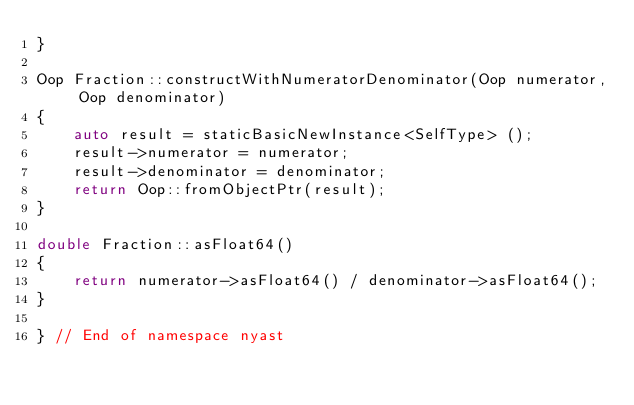Convert code to text. <code><loc_0><loc_0><loc_500><loc_500><_C++_>}

Oop Fraction::constructWithNumeratorDenominator(Oop numerator, Oop denominator)
{
    auto result = staticBasicNewInstance<SelfType> ();
    result->numerator = numerator;
    result->denominator = denominator;
    return Oop::fromObjectPtr(result);
}

double Fraction::asFloat64()
{
    return numerator->asFloat64() / denominator->asFloat64();
}

} // End of namespace nyast
</code> 